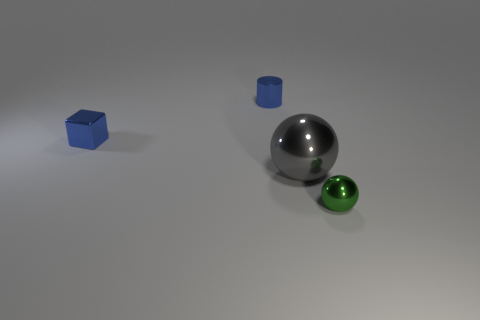There is a green thing that is in front of the tiny blue shiny cube on the left side of the ball to the left of the tiny shiny ball; what shape is it?
Ensure brevity in your answer.  Sphere. There is a sphere that is the same size as the metallic block; what is its color?
Your response must be concise. Green. How many other large gray objects are the same shape as the large metal thing?
Provide a succinct answer. 0. Does the green shiny object have the same size as the blue metal thing that is on the left side of the small blue metal cylinder?
Keep it short and to the point. Yes. What is the shape of the small metal thing that is right of the gray shiny sphere that is right of the small blue cylinder?
Offer a very short reply. Sphere. Are there fewer small green metal balls that are behind the green shiny object than large metallic things?
Offer a very short reply. Yes. There is a tiny metal thing that is the same color as the small metallic cylinder; what is its shape?
Ensure brevity in your answer.  Cube. How many green balls have the same size as the green shiny object?
Offer a terse response. 0. There is a shiny thing that is to the right of the gray sphere; what shape is it?
Give a very brief answer. Sphere. Are there fewer green metal spheres than spheres?
Offer a terse response. Yes. 